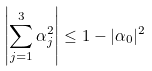<formula> <loc_0><loc_0><loc_500><loc_500>\left | \sum _ { j = 1 } ^ { 3 } \alpha _ { j } ^ { 2 } \right | \leq 1 - | \alpha _ { 0 } | ^ { 2 }</formula> 